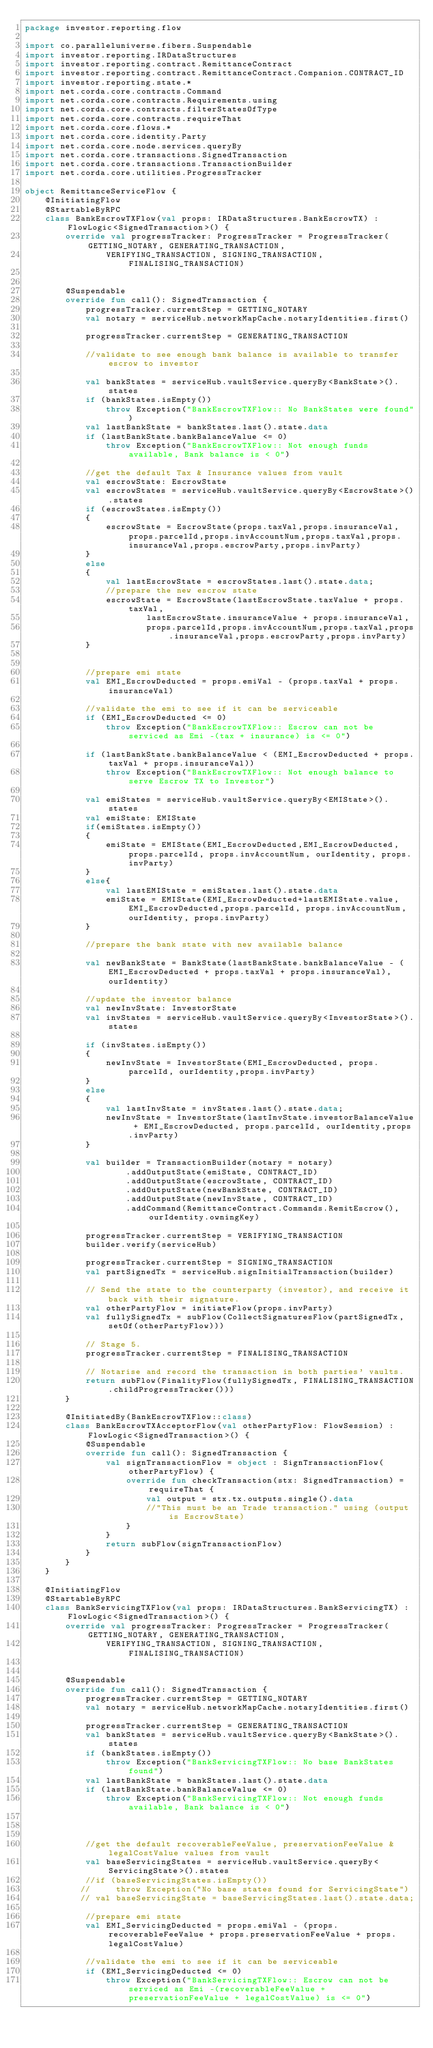<code> <loc_0><loc_0><loc_500><loc_500><_Kotlin_>package investor.reporting.flow

import co.paralleluniverse.fibers.Suspendable
import investor.reporting.IRDataStructures
import investor.reporting.contract.RemittanceContract
import investor.reporting.contract.RemittanceContract.Companion.CONTRACT_ID
import investor.reporting.state.*
import net.corda.core.contracts.Command
import net.corda.core.contracts.Requirements.using
import net.corda.core.contracts.filterStatesOfType
import net.corda.core.contracts.requireThat
import net.corda.core.flows.*
import net.corda.core.identity.Party
import net.corda.core.node.services.queryBy
import net.corda.core.transactions.SignedTransaction
import net.corda.core.transactions.TransactionBuilder
import net.corda.core.utilities.ProgressTracker

object RemittanceServiceFlow {
    @InitiatingFlow
    @StartableByRPC
    class BankEscrowTXFlow(val props: IRDataStructures.BankEscrowTX) : FlowLogic<SignedTransaction>() {
        override val progressTracker: ProgressTracker = ProgressTracker(GETTING_NOTARY, GENERATING_TRANSACTION,
                VERIFYING_TRANSACTION, SIGNING_TRANSACTION, FINALISING_TRANSACTION)


        @Suspendable
        override fun call(): SignedTransaction {
            progressTracker.currentStep = GETTING_NOTARY
            val notary = serviceHub.networkMapCache.notaryIdentities.first()

            progressTracker.currentStep = GENERATING_TRANSACTION

            //validate to see enough bank balance is available to transfer escrow to investor

            val bankStates = serviceHub.vaultService.queryBy<BankState>().states
            if (bankStates.isEmpty())
                throw Exception("BankEscrowTXFlow:: No BankStates were found")
            val lastBankState = bankStates.last().state.data
            if (lastBankState.bankBalanceValue <= 0)
                throw Exception("BankEscrowTXFlow:: Not enough funds available, Bank balance is < 0")

            //get the default Tax & Insurance values from vault
            val escrowState: EscrowState
            val escrowStates = serviceHub.vaultService.queryBy<EscrowState>().states
            if (escrowStates.isEmpty())
            {
                escrowState = EscrowState(props.taxVal,props.insuranceVal,props.parcelId,props.invAccountNum,props.taxVal,props.insuranceVal,props.escrowParty,props.invParty)
            }
            else
            {
                val lastEscrowState = escrowStates.last().state.data;
                //prepare the new escrow state
                escrowState = EscrowState(lastEscrowState.taxValue + props.taxVal,
                        lastEscrowState.insuranceValue + props.insuranceVal,
                        props.parcelId,props.invAccountNum,props.taxVal,props.insuranceVal,props.escrowParty,props.invParty)
            }


            //prepare emi state
            val EMI_EscrowDeducted = props.emiVal - (props.taxVal + props.insuranceVal)

            //validate the emi to see if it can be serviceable
            if (EMI_EscrowDeducted <= 0)
                throw Exception("BankEscrowTXFlow:: Escrow can not be serviced as Emi -(tax + insurance) is <= 0")

            if (lastBankState.bankBalanceValue < (EMI_EscrowDeducted + props.taxVal + props.insuranceVal))
                throw Exception("BankEscrowTXFlow:: Not enough balance to serve Escrow TX to Investor")

            val emiStates = serviceHub.vaultService.queryBy<EMIState>().states
            val emiState: EMIState
            if(emiStates.isEmpty())
            {
                emiState = EMIState(EMI_EscrowDeducted,EMI_EscrowDeducted, props.parcelId, props.invAccountNum, ourIdentity, props.invParty)
            }
            else{
                val lastEMIState = emiStates.last().state.data
                emiState = EMIState(EMI_EscrowDeducted+lastEMIState.value,EMI_EscrowDeducted,props.parcelId, props.invAccountNum, ourIdentity, props.invParty)
            }

            //prepare the bank state with new available balance

            val newBankState = BankState(lastBankState.bankBalanceValue - (EMI_EscrowDeducted + props.taxVal + props.insuranceVal), ourIdentity)

            //update the investor balance
            val newInvState: InvestorState
            val invStates = serviceHub.vaultService.queryBy<InvestorState>().states

            if (invStates.isEmpty())
            {
                newInvState = InvestorState(EMI_EscrowDeducted, props.parcelId, ourIdentity,props.invParty)
            }
            else
            {
                val lastInvState = invStates.last().state.data;
                newInvState = InvestorState(lastInvState.investorBalanceValue + EMI_EscrowDeducted, props.parcelId, ourIdentity,props.invParty)
            }

            val builder = TransactionBuilder(notary = notary)
                    .addOutputState(emiState, CONTRACT_ID)
                    .addOutputState(escrowState, CONTRACT_ID)
                    .addOutputState(newBankState, CONTRACT_ID)
                    .addOutputState(newInvState, CONTRACT_ID)
                    .addCommand(RemittanceContract.Commands.RemitEscrow(), ourIdentity.owningKey)

            progressTracker.currentStep = VERIFYING_TRANSACTION
            builder.verify(serviceHub)

            progressTracker.currentStep = SIGNING_TRANSACTION
            val partSignedTx = serviceHub.signInitialTransaction(builder)

            // Send the state to the counterparty (investor), and receive it back with their signature.
            val otherPartyFlow = initiateFlow(props.invParty)
            val fullySignedTx = subFlow(CollectSignaturesFlow(partSignedTx, setOf(otherPartyFlow)))

            // Stage 5.
            progressTracker.currentStep = FINALISING_TRANSACTION

            // Notarise and record the transaction in both parties' vaults.
            return subFlow(FinalityFlow(fullySignedTx, FINALISING_TRANSACTION.childProgressTracker()))
        }

        @InitiatedBy(BankEscrowTXFlow::class)
        class BankEscrowTXAcceptorFlow(val otherPartyFlow: FlowSession) : FlowLogic<SignedTransaction>() {
            @Suspendable
            override fun call(): SignedTransaction {
                val signTransactionFlow = object : SignTransactionFlow(otherPartyFlow) {
                    override fun checkTransaction(stx: SignedTransaction) = requireThat {
                        val output = stx.tx.outputs.single().data
                        //"This must be an Trade transaction." using (output is EscrowState)
                    }
                }
                return subFlow(signTransactionFlow)
            }
        }
    }

    @InitiatingFlow
    @StartableByRPC
    class BankServicingTXFlow(val props: IRDataStructures.BankServicingTX) : FlowLogic<SignedTransaction>() {
        override val progressTracker: ProgressTracker = ProgressTracker(GETTING_NOTARY, GENERATING_TRANSACTION,
                VERIFYING_TRANSACTION, SIGNING_TRANSACTION, FINALISING_TRANSACTION)


        @Suspendable
        override fun call(): SignedTransaction {
            progressTracker.currentStep = GETTING_NOTARY
            val notary = serviceHub.networkMapCache.notaryIdentities.first()

            progressTracker.currentStep = GENERATING_TRANSACTION
            val bankStates = serviceHub.vaultService.queryBy<BankState>().states
            if (bankStates.isEmpty())
                throw Exception("BankServicingTXFlow:: No base BankStates found")
            val lastBankState = bankStates.last().state.data
            if (lastBankState.bankBalanceValue <= 0)
                throw Exception("BankServicingTXFlow:: Not enough funds available, Bank balance is < 0")



            //get the default recoverableFeeValue, preservationFeeValue & legalCostValue values from vault
            val baseServicingStates = serviceHub.vaultService.queryBy<ServicingState>().states
            //if (baseServicingStates.isEmpty())
           //     throw Exception("No base states found for ServicingState")
           // val baseServicingState = baseServicingStates.last().state.data;

            //prepare emi state
            val EMI_ServicingDeducted = props.emiVal - (props.recoverableFeeValue + props.preservationFeeValue + props.legalCostValue)

            //validate the emi to see if it can be serviceable
            if (EMI_ServicingDeducted <= 0)
                throw Exception("BankServicingTXFlow:: Escrow can not be serviced as Emi -(recoverableFeeValue + preservationFeeValue + legalCostValue) is <= 0")
</code> 